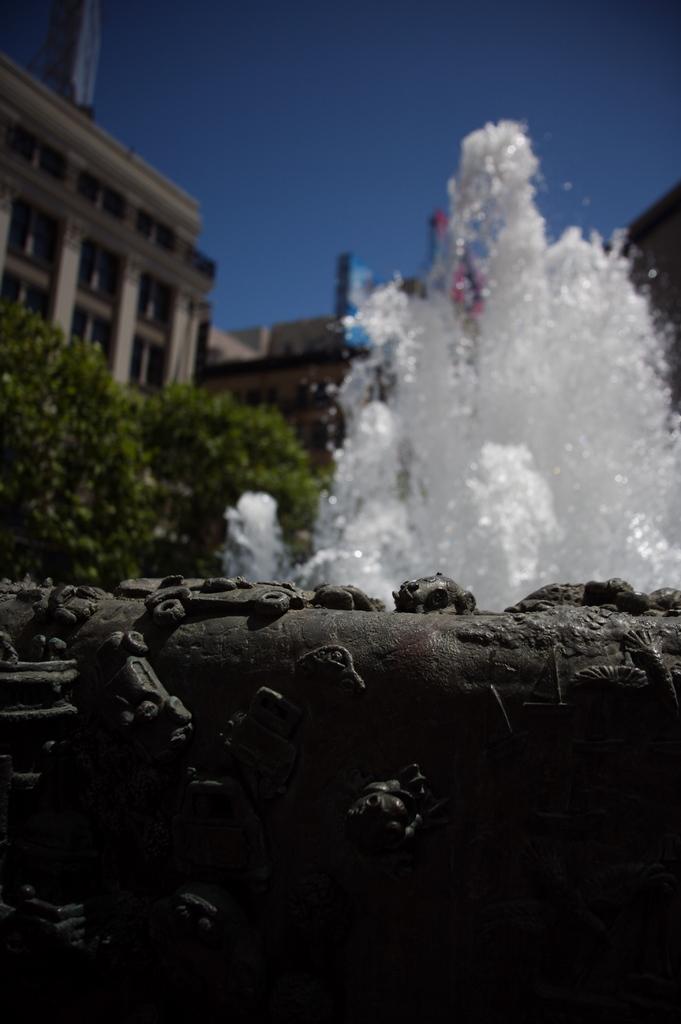Could you give a brief overview of what you see in this image? In this image I can see a fountain. Background I can see trees in green color, buildings in cream and brown color, and sky in blue color. 